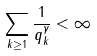<formula> <loc_0><loc_0><loc_500><loc_500>\sum _ { k \geq 1 } \frac { 1 } { q _ { k } ^ { \gamma } } < \infty</formula> 